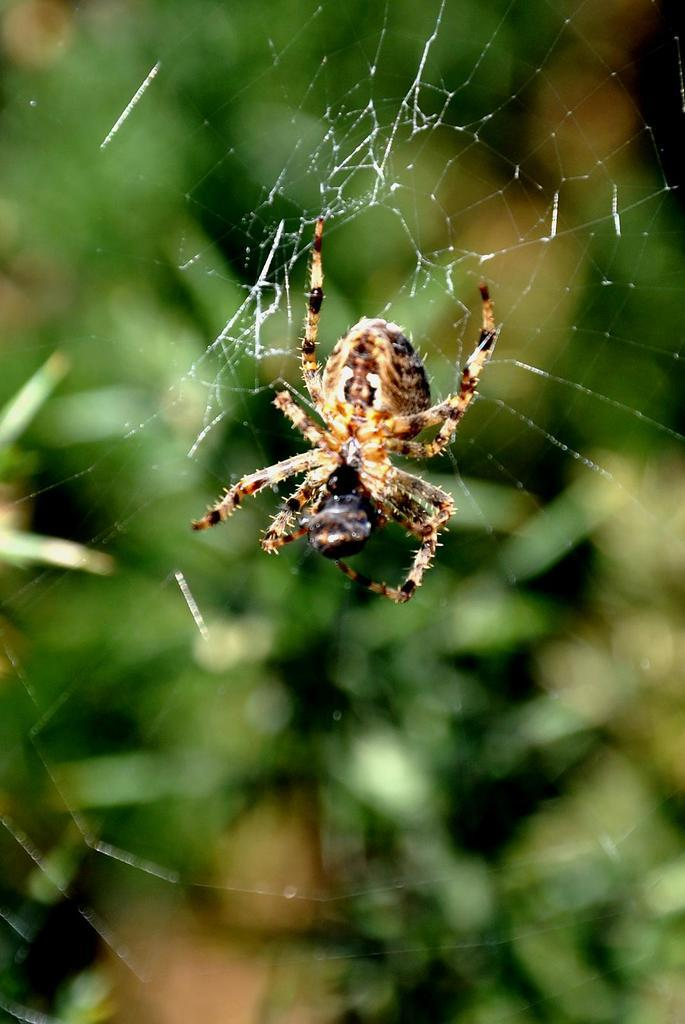What is the main subject of the image? The main subject of the image is a spider. Can you describe the appearance of the spider? The spider has black and brown color. What can be seen in the background of the image? The background of the image is green. What month is it in the image? The month is not mentioned or depicted in the image, so it cannot be determined. 